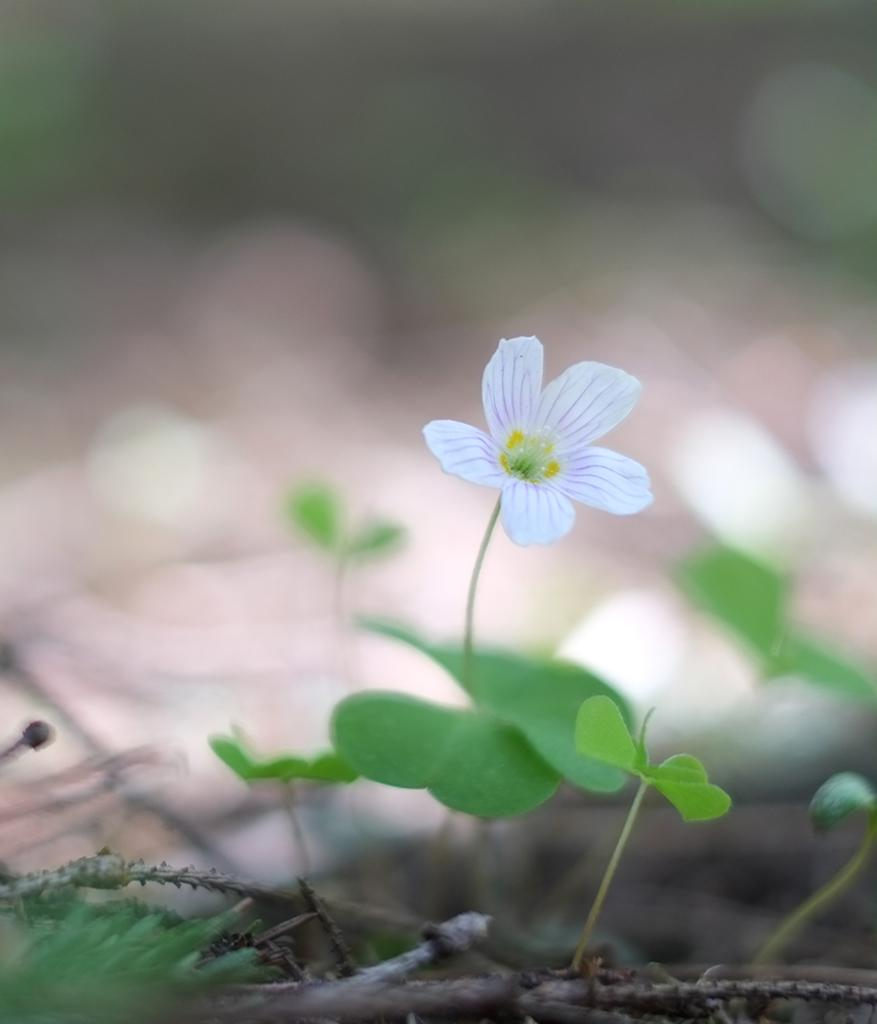What type of flower is present in the image? There is a white color flower in the image. What color are the leaves in the image? There are green color leaves in the image. What type of cake is being pulled by the flower in the image? There is no cake present in the image, and the flower is not pulling anything. 